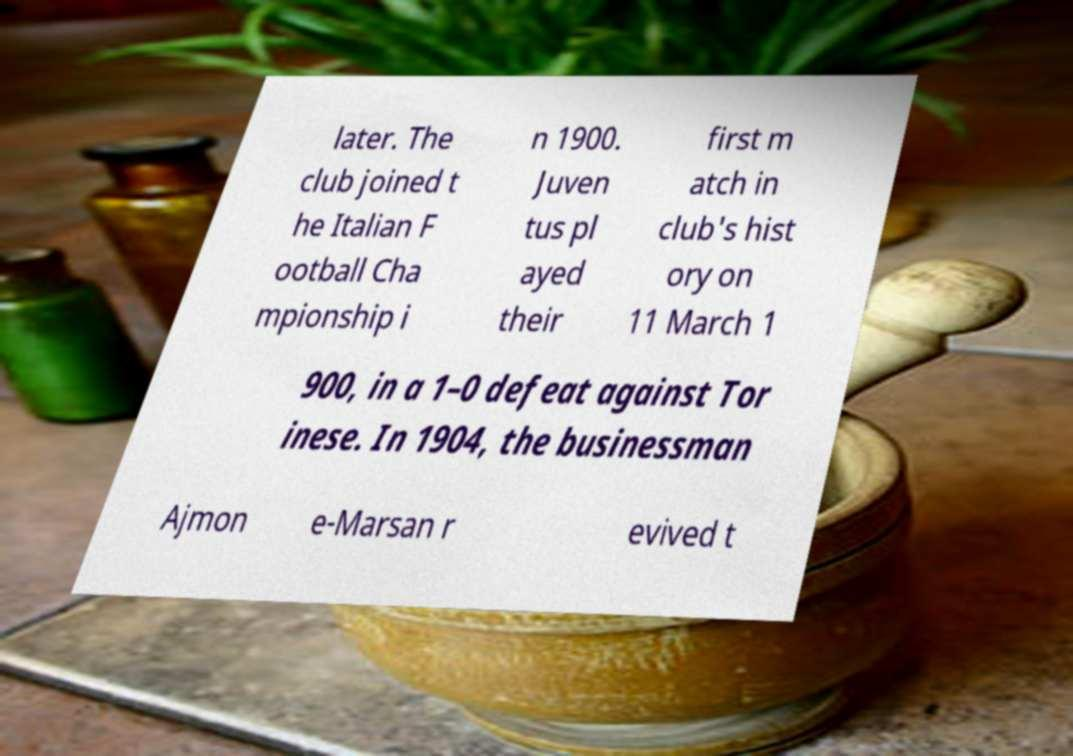Could you extract and type out the text from this image? later. The club joined t he Italian F ootball Cha mpionship i n 1900. Juven tus pl ayed their first m atch in club's hist ory on 11 March 1 900, in a 1–0 defeat against Tor inese. In 1904, the businessman Ajmon e-Marsan r evived t 